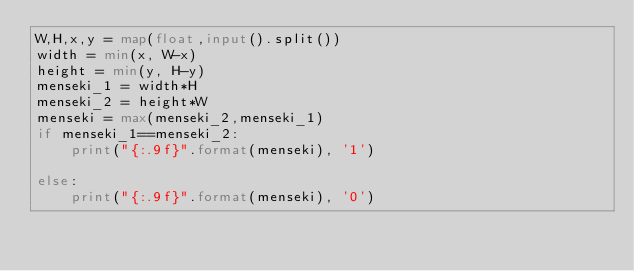Convert code to text. <code><loc_0><loc_0><loc_500><loc_500><_Python_>W,H,x,y = map(float,input().split())
width = min(x, W-x)
height = min(y, H-y)
menseki_1 = width*H
menseki_2 = height*W
menseki = max(menseki_2,menseki_1)
if menseki_1==menseki_2:
    print("{:.9f}".format(menseki), '1')

else:
    print("{:.9f}".format(menseki), '0')
</code> 